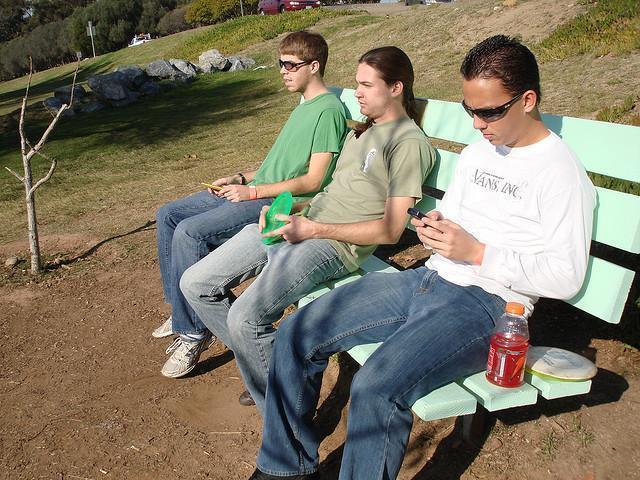How many people are in the picture?
Give a very brief answer. 3. How many yellow umbrellas are there?
Give a very brief answer. 0. 